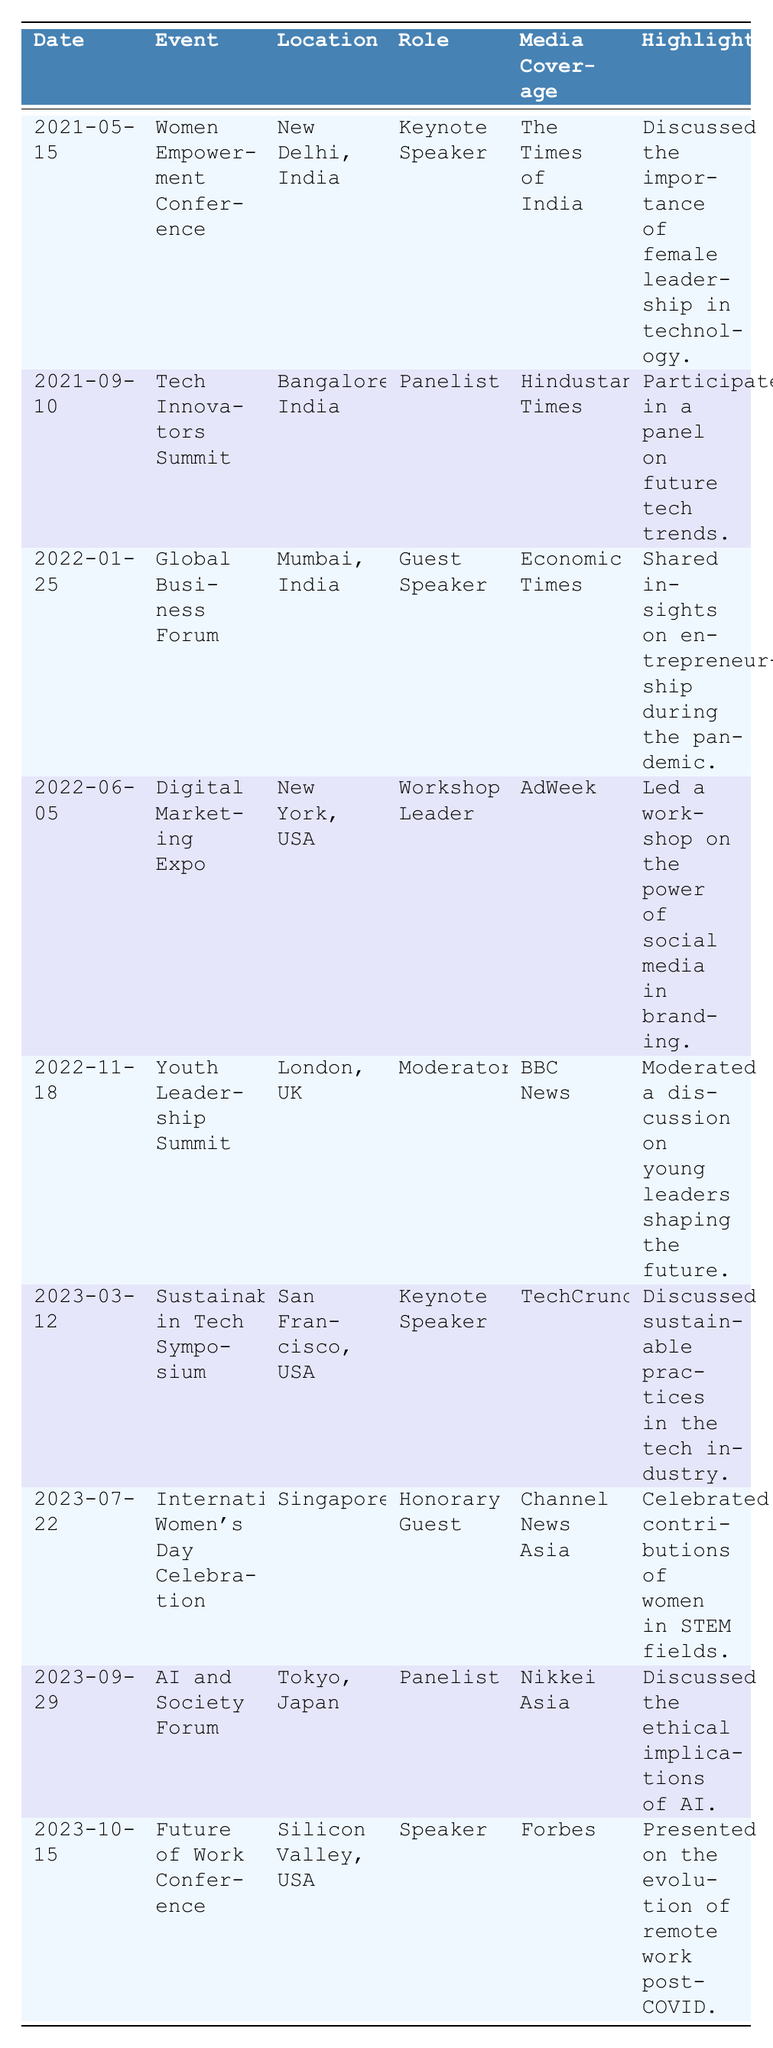What was Mreenal Deshraj's role at the Women Empowerment Conference? The table indicates that Mreenal Deshraj was the Keynote Speaker at the Women Empowerment Conference on May 15, 2021.
Answer: Keynote Speaker In which location did Mreenal Deshraj speak as a Guest Speaker? According to the table, Mreenal Deshraj was a Guest Speaker at the Global Business Forum located in Mumbai, India on January 25, 2022.
Answer: Mumbai, India How many events did Mreenal Deshraj attend as a panelist? The table shows that there are two events where Mreenal Deshraj participated as a Panelist: the Tech Innovators Summit and the AI and Society Forum.
Answer: 2 What media outlet covered Mreenal Deshraj's participation in the Digital Marketing Expo? The table states that AdWeek covered Mreenal Deshraj's participation in the Digital Marketing Expo on June 5, 2022.
Answer: AdWeek Which event did Mreenal Deshraj attend on March 12, 2023? The table lists that on March 12, 2023, Mreenal Deshraj attended the Sustainability in Tech Symposium.
Answer: Sustainability in Tech Symposium Was Mreenal Deshraj a speaker at more events than she was a moderator? By counting the roles: She was a speaker at 4 events (Keynote, Guest, and Workshop Speaker) and a moderator at 1 event. Therefore, she was a speaker at more events than a moderator.
Answer: Yes What significant topic did Mreenal Deshraj discuss at the Sustainability in Tech Symposium? The table highlights that at the Sustainability in Tech Symposium, she discussed sustainable practices in the tech industry.
Answer: Sustainable practices in the tech industry List all the events where Mreenal Deshraj served as a Keynote Speaker. The table shows that Mreenal Deshraj served as a Keynote Speaker at two events: the Women Empowerment Conference and the Sustainability in Tech Symposium.
Answer: Women Empowerment Conference, Sustainability in Tech Symposium Which event took place last in 2023? From the table, the last event listed in 2023 is the Future of Work Conference, which took place on October 15, 2023.
Answer: Future of Work Conference How many events occurred after 2022, and what are their names? There are four events that occurred after 2022: Sustainability in Tech Symposium, International Women’s Day Celebration, AI and Society Forum, and Future of Work Conference.
Answer: 4 events: Sustainability in Tech Symposium, International Women’s Day Celebration, AI and Society Forum, Future of Work Conference What is the main theme of Mreenal Deshraj's participation in these events? Analyzing the highlights, the main theme across Mreenal Deshraj's participation appears to be the empowerment of women, leadership in technology, and sustainability.
Answer: Empowerment of women, leadership in technology, sustainability 